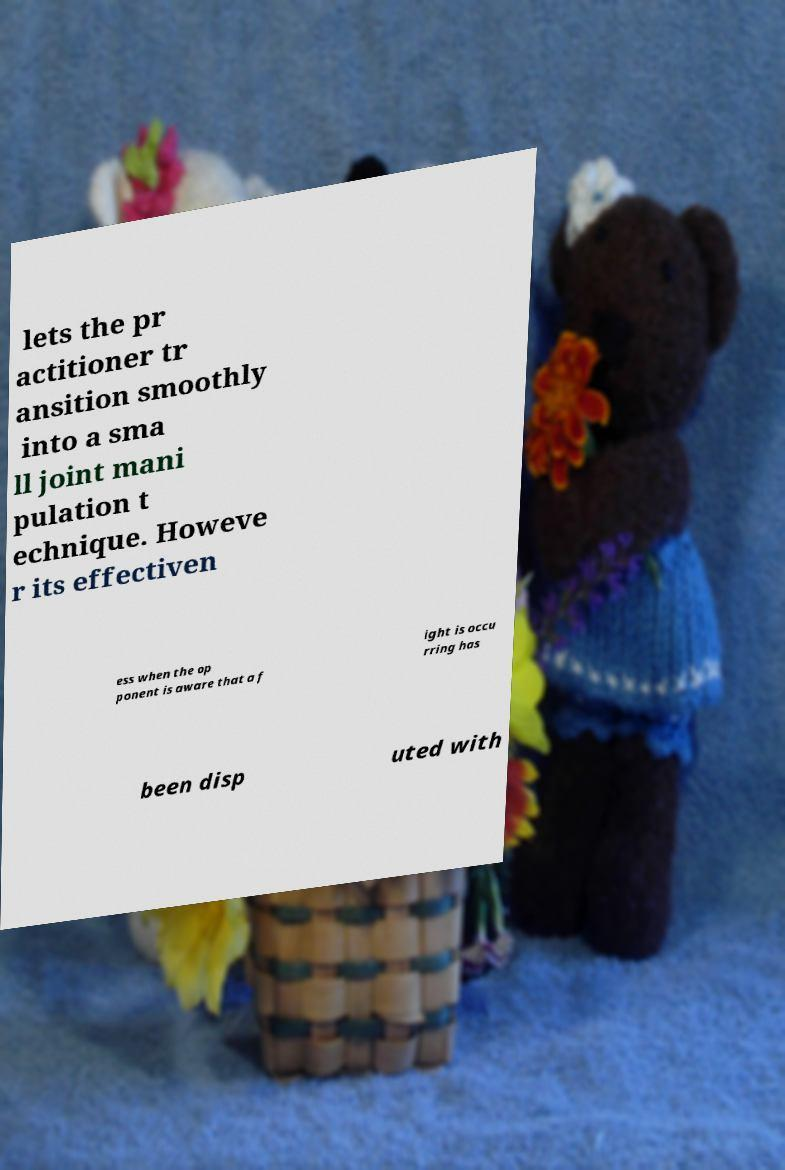I need the written content from this picture converted into text. Can you do that? lets the pr actitioner tr ansition smoothly into a sma ll joint mani pulation t echnique. Howeve r its effectiven ess when the op ponent is aware that a f ight is occu rring has been disp uted with 